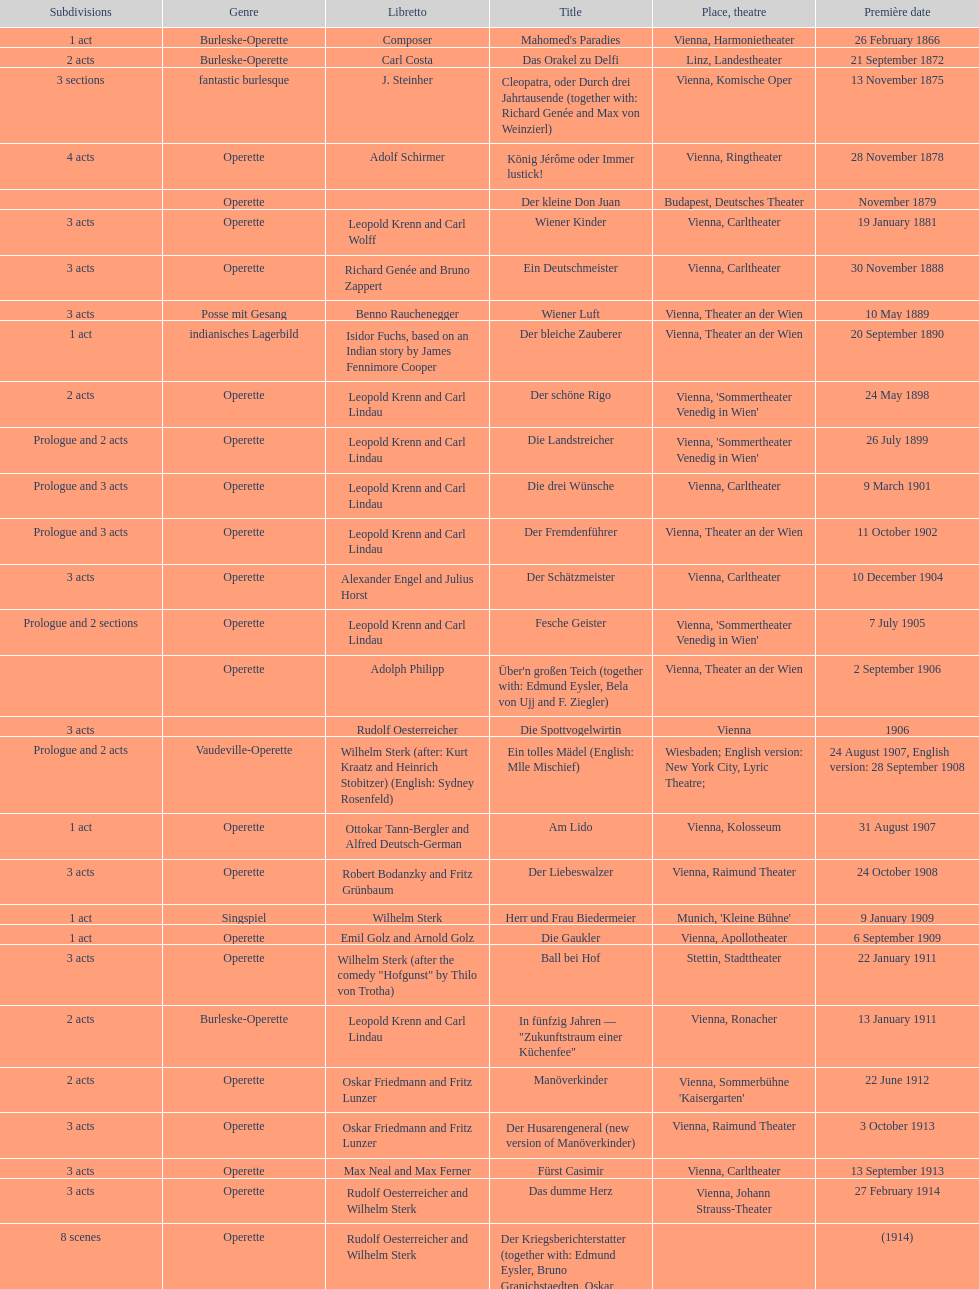All the dates are no later than what year? 1958. 